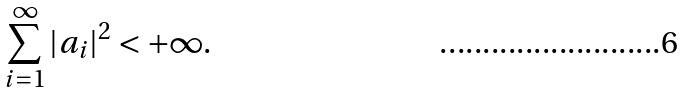Convert formula to latex. <formula><loc_0><loc_0><loc_500><loc_500>\sum _ { i = 1 } ^ { \infty } | a _ { i } | ^ { 2 } < + \infty .</formula> 